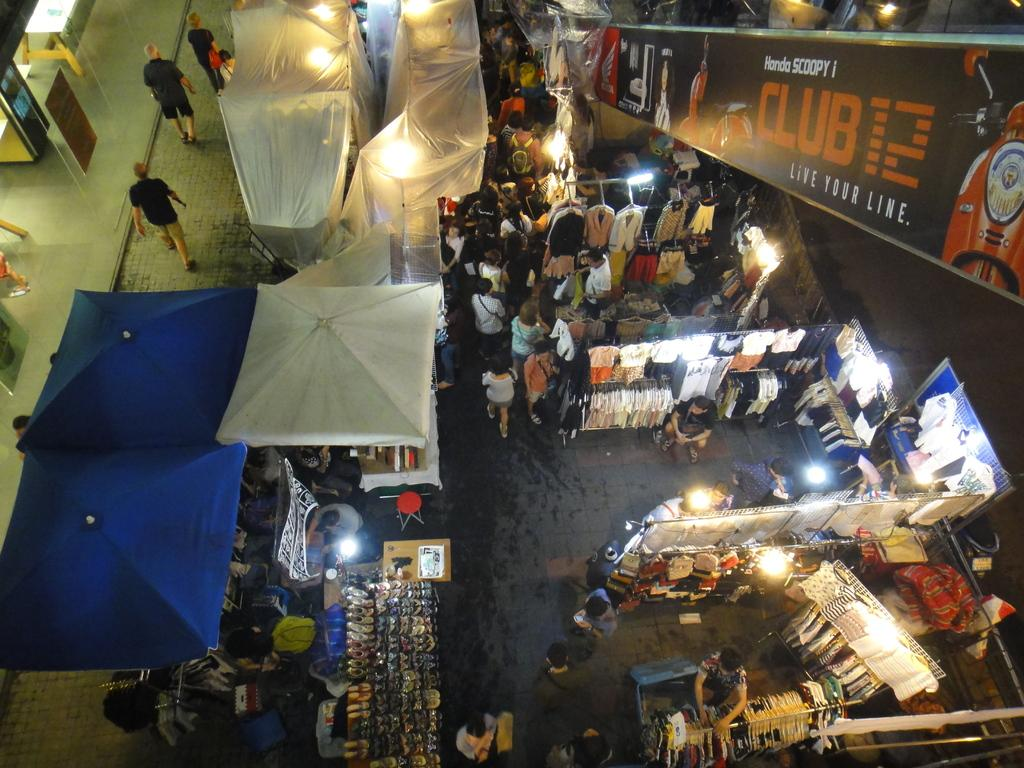How many people are in the group visible in the image? There is a group of people in the image, but the exact number is not specified. What type of temporary shelters can be seen in the image? There are tents in the image. What kind of signage is present in the image? There are posters in the image. What can be used to provide illumination in the image? There are lights in the image. What type of footwear is visible in the image? There is footwear in the image. What type of clothing is visible in the image? There are clothes in the image. What type of furniture is present in the image? There are tables in the image. What are some people doing in the image? Some people are walking on the floor in the image. Can you describe the destruction caused by the kiss in the image? There is no kiss or destruction present in the image. How can we help the people in the image who are seeking assistance? The image does not indicate that anyone is seeking help, nor does it provide any information on how to help them. 